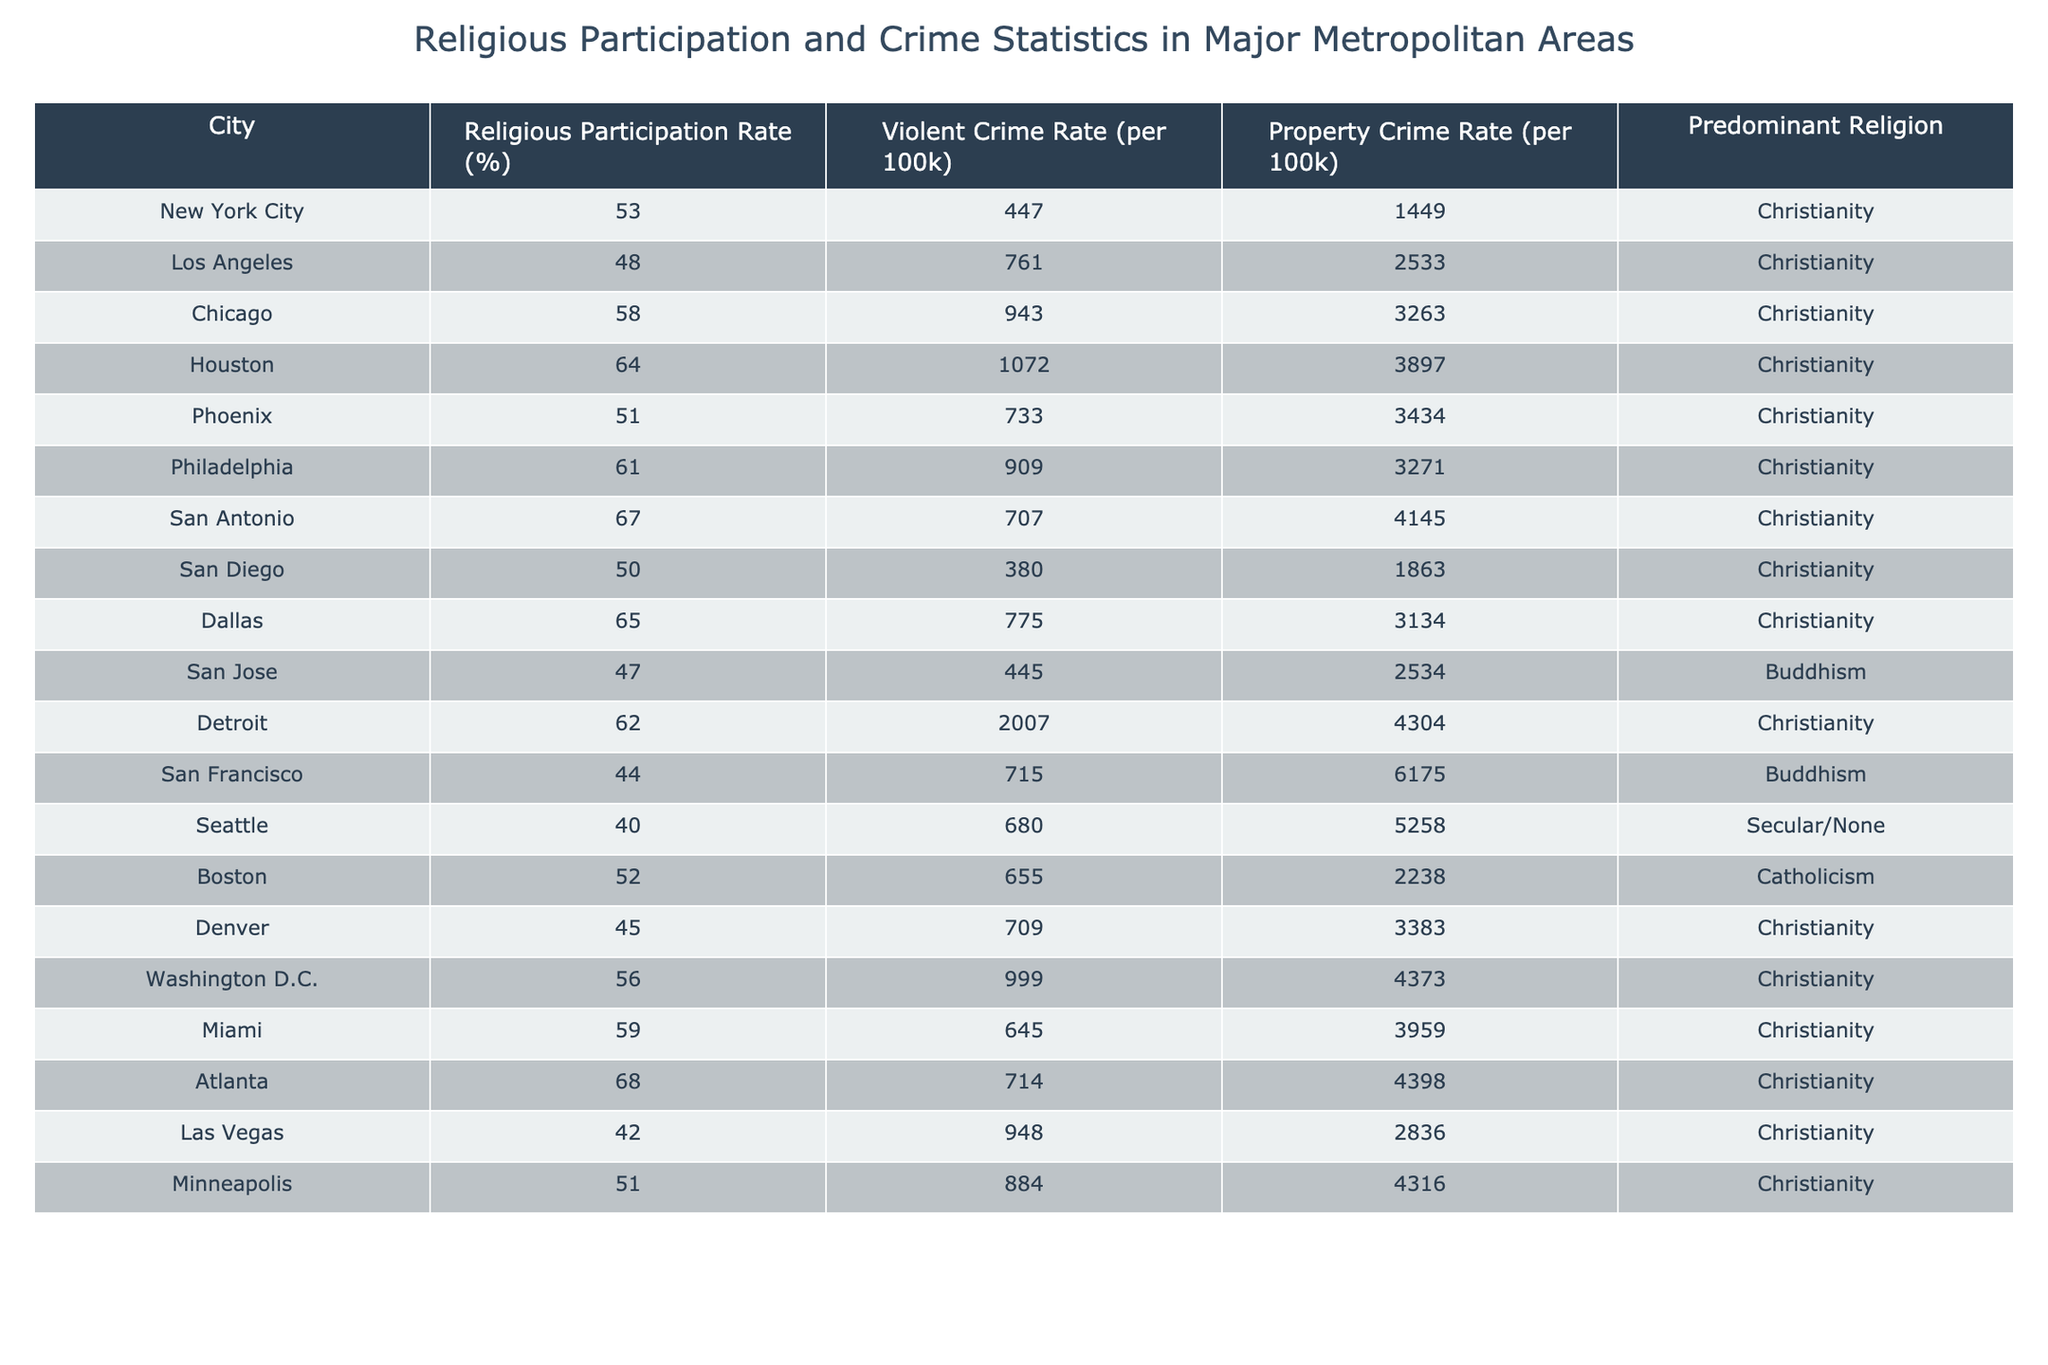What is the religious participation rate for San Diego? By looking at the "Religious Participation Rate (%)" column for San Diego, we can see it is 50%.
Answer: 50% Which city has the highest violent crime rate? The "Violent Crime Rate (per 100k)" column indicates that Detroit has the highest rate at 2007 per 100k.
Answer: Detroit What is the average property crime rate across all cities? To find the average, we sum the property crime rates: (1449 + 2533 + 3263 + 3897 + 3434 + 3271 + 4145 + 1863 + 3134 + 2534 + 4304 + 6175 + 5258 + 2238 + 3383 + 4373 + 3959 + 4398 + 2836 + 4316) = 68136. Then, we divide by the number of cities, which is 20: 68136 / 20 = 3406.8.
Answer: 3406.8 Is there a correlation between religious participation rates and violent crime rates in this dataset? To analyze this, we can compare the religious participation rates with violent crime rates. Generally, cities with higher participation rates like San Antonio (67%) have lower violent crime rates (707), while lower participation rates like Los Angeles (48%) have higher rates (761). However, this trend is not consistent across all cities, indicating no definitive correlation.
Answer: No definitive correlation In which city does the predominant religion differ from Christianity? By examining the "Predominant Religion" column, we see that San Jose and San Francisco predominantly have Buddhism and Secular/None, respectively, whereas other cities specify Christianity.
Answer: San Jose and San Francisco What is the difference in violent crime rates between Houston and Atlanta? To find the difference, we subtract Atlanta's violent crime rate (714) from Houston's (1072): 1072 - 714 = 358.
Answer: 358 How many cities have a religious participation rate of 60% or higher? By counting the entries in the "Religious Participation Rate (%)" column that are 60% or above, we find 6 cities: Chicago, Houston, San Antonio, Philadelphia, Miami, and Atlanta.
Answer: 6 Is the property crime rate in San Diego higher than that in New York City? The property crime rate for San Diego is 1863 and for New York City is 1449. Since 1863 is greater than 1449, we conclude that San Diego has a higher property crime rate.
Answer: Yes Which city has the lowest religious participation rate and what is that rate? San Francisco has the lowest religious participation rate at 44%.
Answer: 44% What is the total violent crime rate for cities with a predominant religion of Christianity? We sum the violent crime rates of all cities with Christianity, which total 15 cities: 447 + 761 + 943 + 1072 + 733 + 909 + 707 + 775 + 999 + 645 + 714 + 948 + 884 + 2007 = 11692.
Answer: 11692 